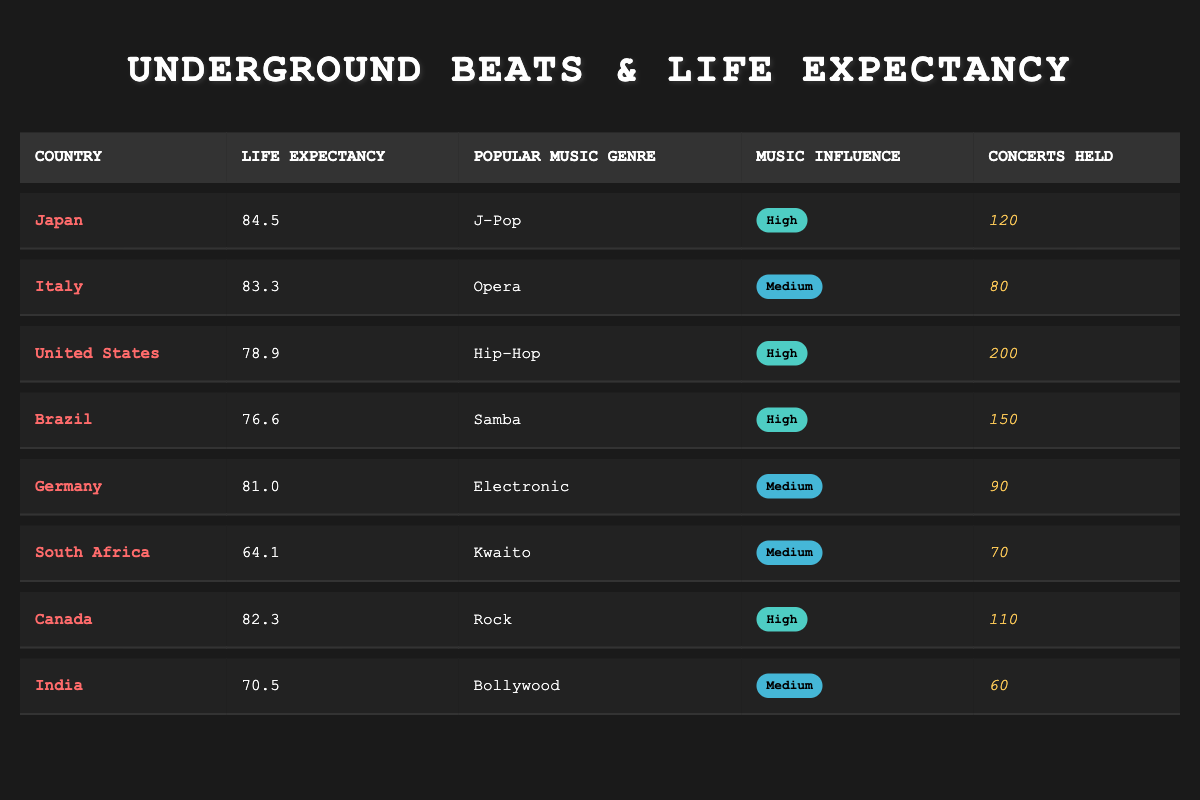What is the life expectancy of Japan? The life expectancy of Japan is given directly in the table under the 'Life Expectancy' column, which states 84.5 years.
Answer: 84.5 How many concerts were held in the United States? The number of concerts held in the United States can be found in the table, in the 'Concerts Held' column, which lists 200 concerts.
Answer: 200 Which country has the lowest life expectancy? To determine the lowest life expectancy, I check the 'Life Expectancy' column. The lowest value is 64.1, which corresponds to South Africa.
Answer: South Africa What is the average life expectancy of the countries listed? To find the average, I add the life expectancies of all countries: (84.5 + 83.3 + 78.9 + 76.6 + 81.0 + 64.1 + 82.3 + 70.5) = 521.8. There are 8 countries, so the average is 521.8 / 8 = 65.225.
Answer: 65.225 Is Hip-Hop the most popular music genre in terms of concerts held? To determine this, I will examine the 'Concerts Held' column. Hip-Hop in the United States has 200 concerts, while other genres have fewer, so it is indeed the highest.
Answer: Yes Do countries with high music influence generally have higher life expectancy? Analyzing the data, the countries with high music influence (Japan, United States, Brazil, Canada) have life expectancies of 84.5, 78.9, 76.6, and 82.3 respectively. The average for these is (84.5 + 78.9 + 76.6 + 82.3) / 4 = 80.575. Countries with medium influence (Italy, Germany, South Africa, India) have averages of (83.3 + 81.0 + 64.1 + 70.5) / 4 = 74.725, thus higher music influence corresponds to higher life expectancy.
Answer: Yes What percentage of concerts held in Japan compared to the total concerts held across all countries? First, calculate the total number of concerts held: 120 + 80 + 200 + 150 + 90 + 70 + 110 + 60 = 920. The percentage of concerts held in Japan is (120 / 920) * 100 = approximately 13.04%.
Answer: 13.04% How does the life expectancy of Canada compare to that of South Africa? The life expectancy of Canada is 82.3 years compared to South Africa's 64.1 years. To find the difference, I subtract: 82.3 - 64.1 = 18.2. Thus, Canada has a higher life expectancy by 18.2 years.
Answer: 18.2 What is the most popular music genre in Brazil? The table lists the popular music genre for Brazil under the 'Popular Music Genre' column, which states it is Samba.
Answer: Samba 